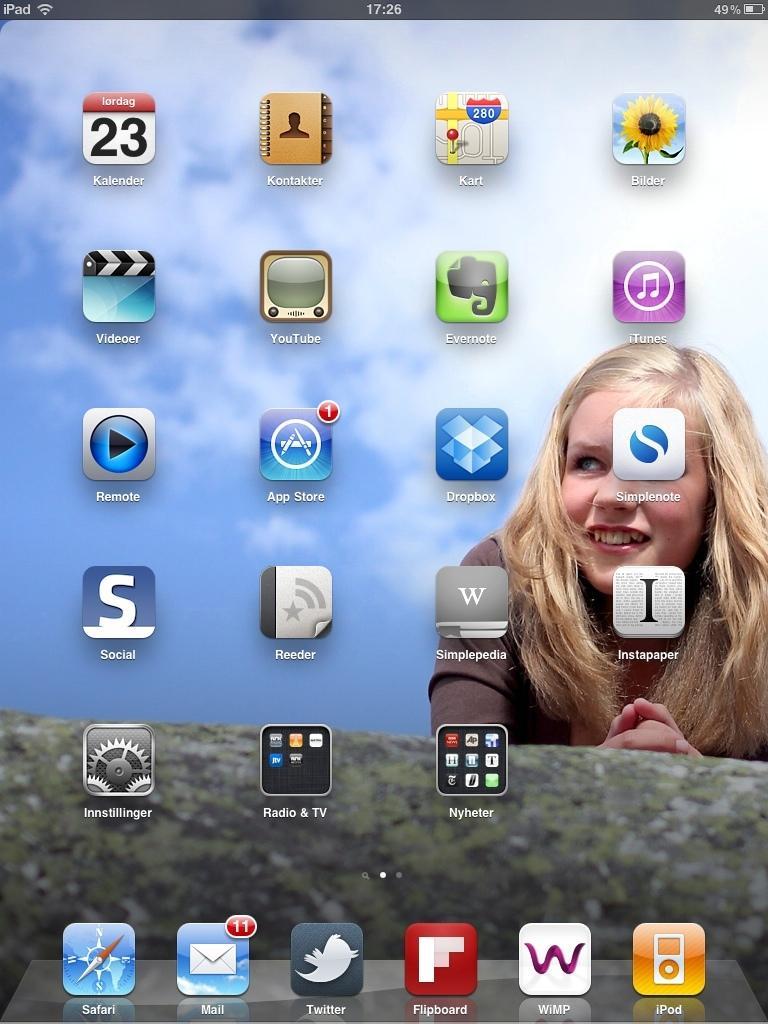Can you describe this image briefly? In the foreground of this picture, there is a screen of a phone where we can see few apps and a woman wallpaper in the background. 